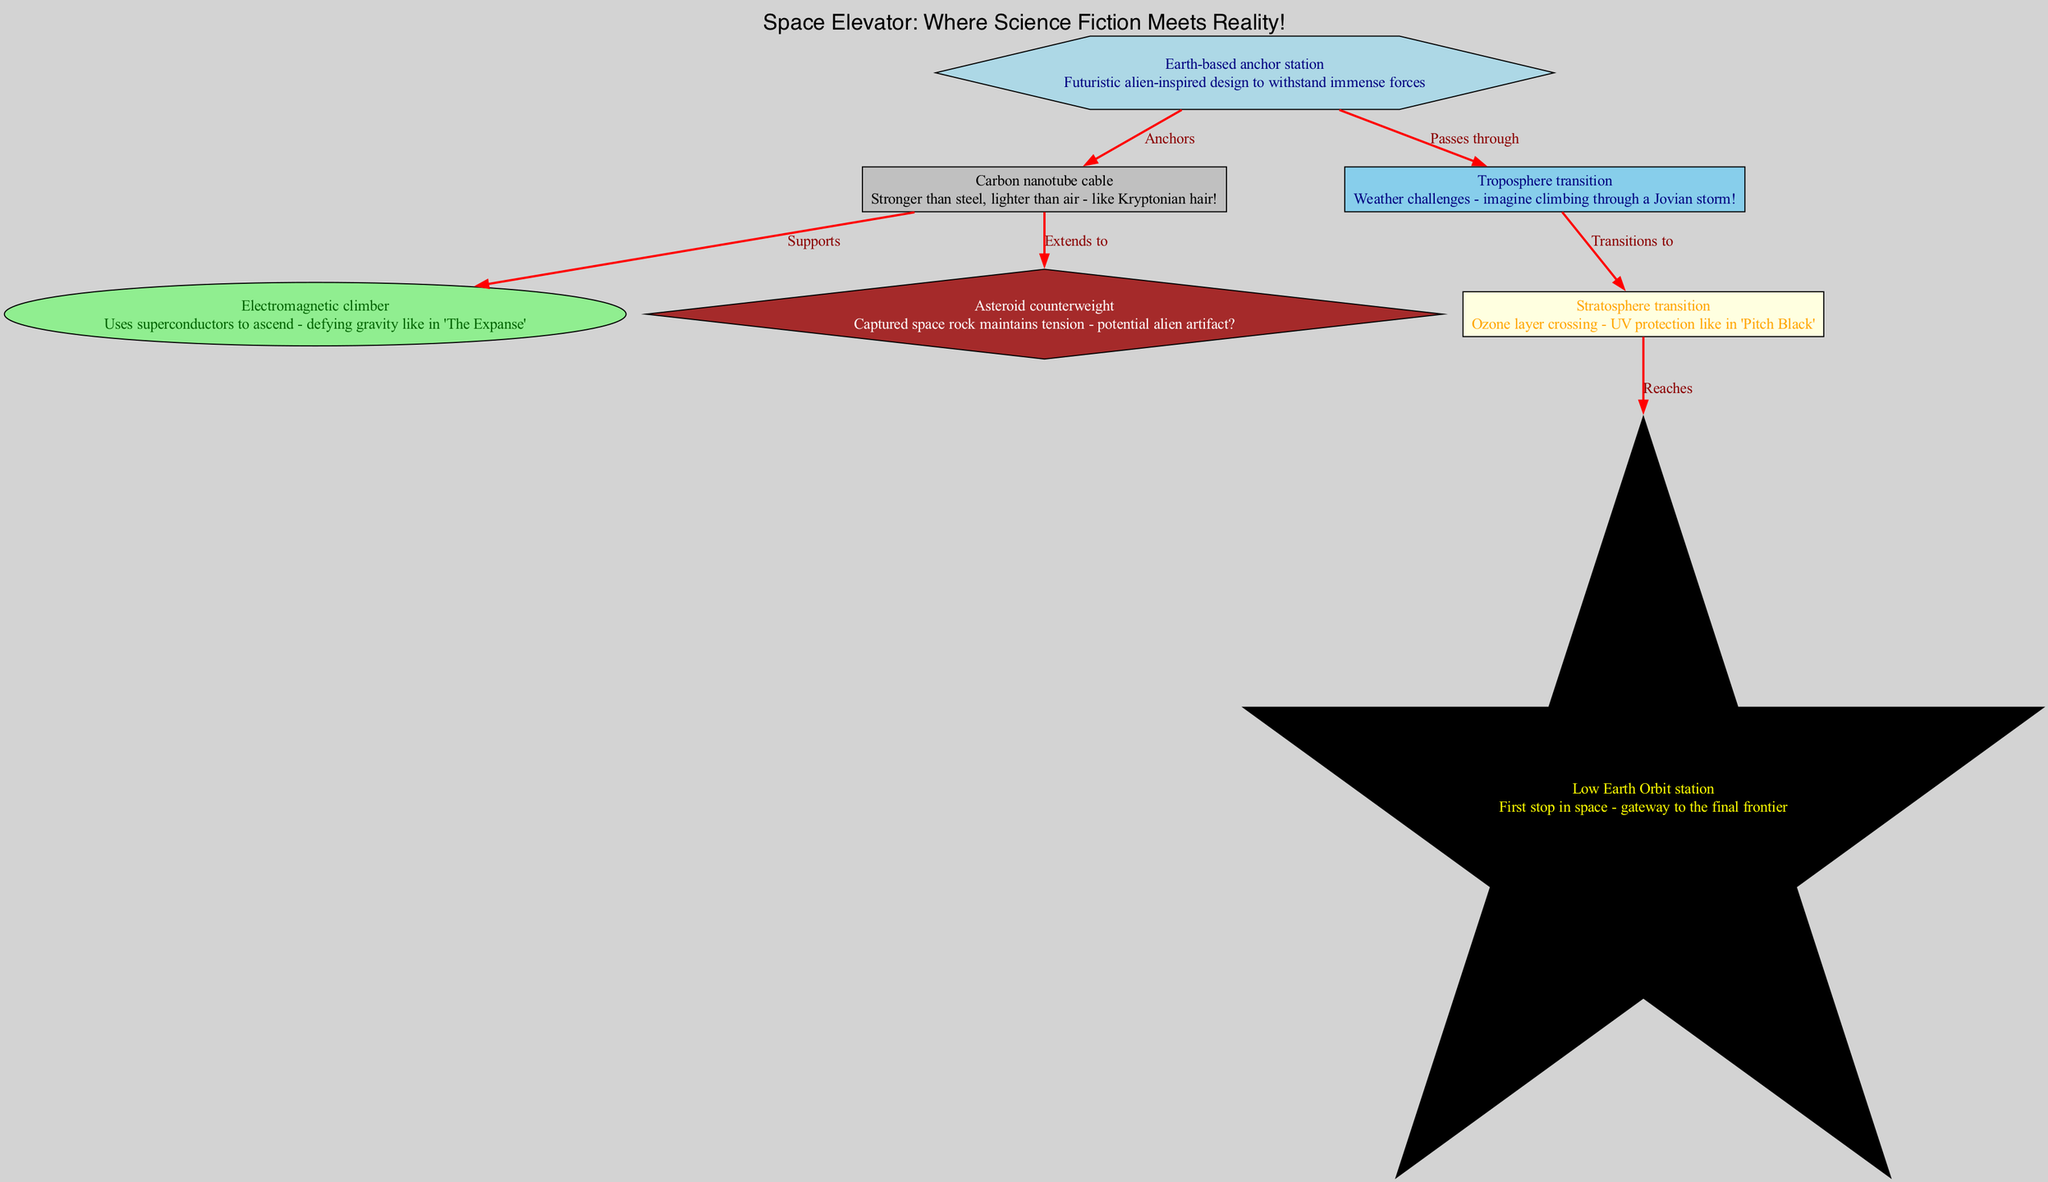What is the label of the node at the base of the diagram? The node at the base of the diagram is labeled "Earth-based anchor station." This information can be directly pulled from the node details provided in the data section.
Answer: Earth-based anchor station How does the climber ascend in the diagram? The climber ascends using superconductors, as indicated in the description of the "Electromagnetic climber." This provides insight into the technology used for climbing in the space elevator system.
Answer: Superconductors What are the two transitions the cable passes through before reaching space? The cable passes through the "troposphere" and "stratosphere" transition zones before it reaches space, according to the edges describing transitions in the data.
Answer: Troposphere, stratosphere What is the color of the cable node in the diagram? The cable node is colored gray, which can be inferred from the node styles assigned to the "cable" element in the diagram generation code.
Answer: Gray How many nodes are present in the diagram? There are seven nodes in total, as counted from the provided data nodes section, which includes all the components involved in the space elevator.
Answer: Seven Why is the asteroid used as a counterweight? The asteroid is used as a counterweight to maintain tension in the system; it's referred to in the description as a "captured space rock," which implies its role in the structural integrity of the space elevator.
Answer: To maintain tension Which atmospheric zone poses weather challenges as noted in the diagram? The "troposphere transition" is noted for its weather challenges in the description, implying difficulty for the climber in that segment of the ascent.
Answer: Troposphere transition What unique material is the cable made from? The cable is made from carbon nanotubes, as explicitly stated in its description, highlighting the innovative material science aspect of the space elevator design.
Answer: Carbon nanotubes Which node serves as the first stop in space? The "Low Earth Orbit station" serves as the first stop in space, clearly mentioned in its node description, indicating its importance in the sequence of the space elevator.
Answer: Low Earth Orbit station 